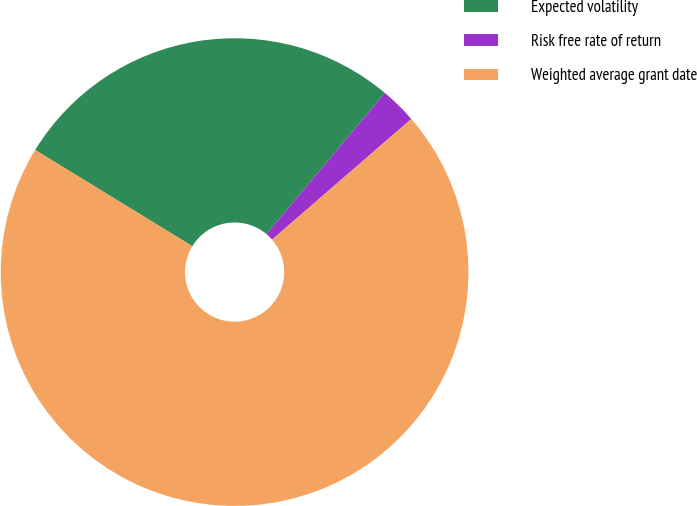<chart> <loc_0><loc_0><loc_500><loc_500><pie_chart><fcel>Expected volatility<fcel>Risk free rate of return<fcel>Weighted average grant date<nl><fcel>27.36%<fcel>2.53%<fcel>70.1%<nl></chart> 